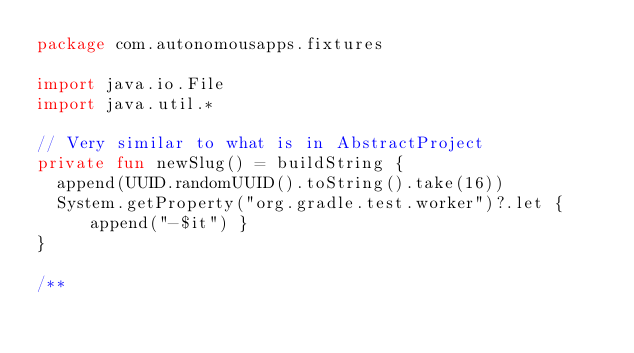<code> <loc_0><loc_0><loc_500><loc_500><_Kotlin_>package com.autonomousapps.fixtures

import java.io.File
import java.util.*

// Very similar to what is in AbstractProject
private fun newSlug() = buildString {
  append(UUID.randomUUID().toString().take(16))
  System.getProperty("org.gradle.test.worker")?.let { append("-$it") }
}

/**</code> 